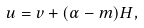<formula> <loc_0><loc_0><loc_500><loc_500>u = v + ( \alpha - m ) H ,</formula> 